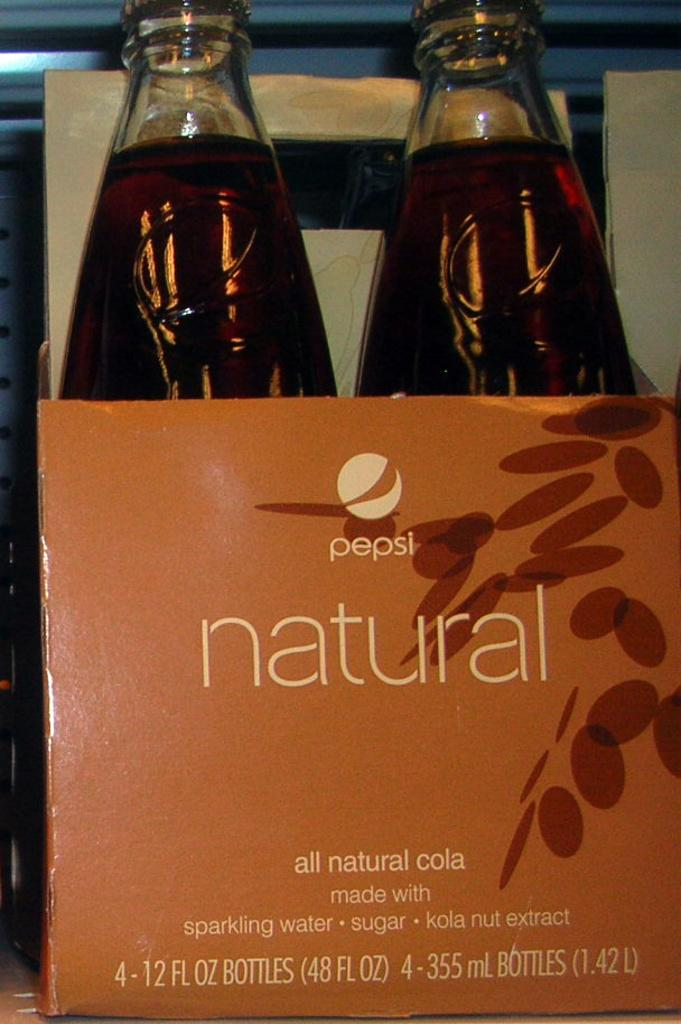<image>
Describe the image concisely. A box of natural Pepsi that is made with sparkling water, sugar and kola nut extract. 